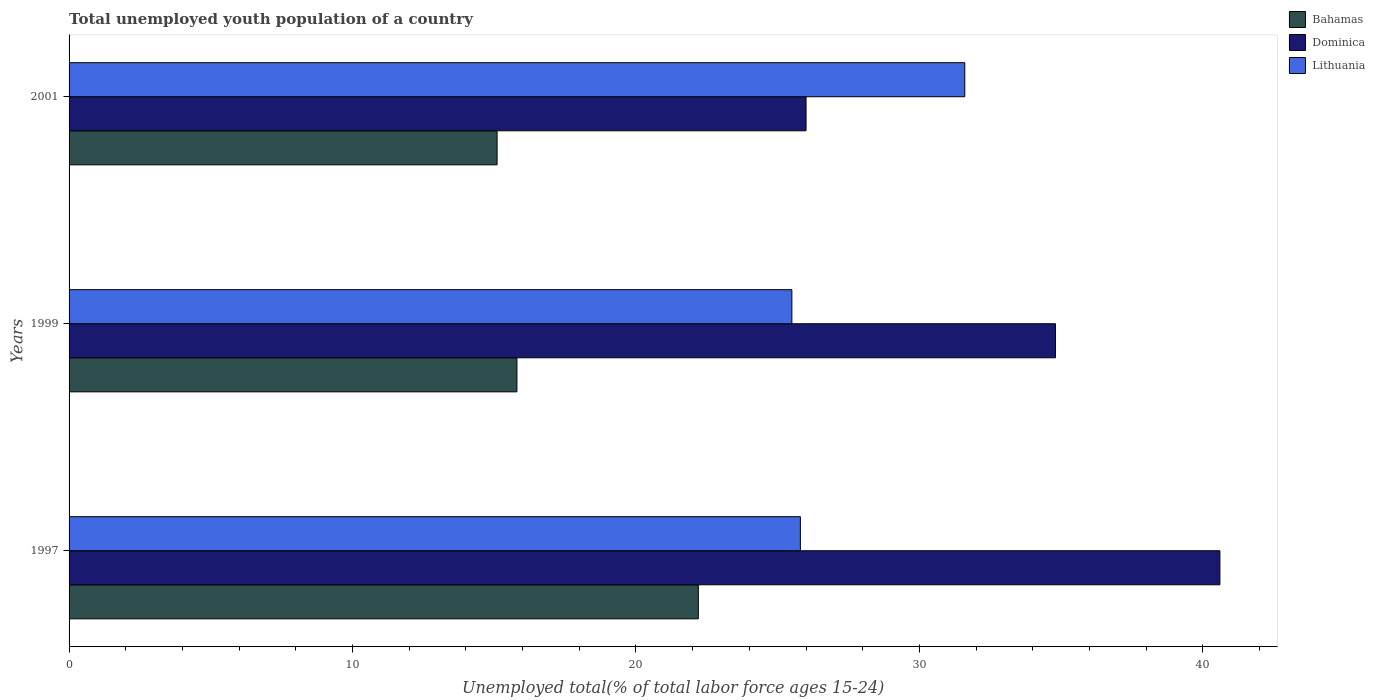Are the number of bars per tick equal to the number of legend labels?
Your answer should be very brief. Yes. What is the label of the 3rd group of bars from the top?
Your answer should be compact. 1997. In how many cases, is the number of bars for a given year not equal to the number of legend labels?
Ensure brevity in your answer.  0. What is the percentage of total unemployed youth population of a country in Dominica in 1999?
Offer a very short reply. 34.8. Across all years, what is the maximum percentage of total unemployed youth population of a country in Dominica?
Ensure brevity in your answer.  40.6. Across all years, what is the minimum percentage of total unemployed youth population of a country in Bahamas?
Provide a succinct answer. 15.1. What is the total percentage of total unemployed youth population of a country in Lithuania in the graph?
Your response must be concise. 82.9. What is the difference between the percentage of total unemployed youth population of a country in Bahamas in 1997 and that in 1999?
Your answer should be compact. 6.4. What is the difference between the percentage of total unemployed youth population of a country in Dominica in 1997 and the percentage of total unemployed youth population of a country in Bahamas in 1999?
Offer a very short reply. 24.8. What is the average percentage of total unemployed youth population of a country in Bahamas per year?
Offer a very short reply. 17.7. In the year 1997, what is the difference between the percentage of total unemployed youth population of a country in Dominica and percentage of total unemployed youth population of a country in Lithuania?
Provide a short and direct response. 14.8. In how many years, is the percentage of total unemployed youth population of a country in Bahamas greater than 18 %?
Provide a short and direct response. 1. What is the ratio of the percentage of total unemployed youth population of a country in Lithuania in 1997 to that in 1999?
Keep it short and to the point. 1.01. Is the percentage of total unemployed youth population of a country in Lithuania in 1999 less than that in 2001?
Offer a very short reply. Yes. What is the difference between the highest and the second highest percentage of total unemployed youth population of a country in Lithuania?
Your answer should be very brief. 5.8. What is the difference between the highest and the lowest percentage of total unemployed youth population of a country in Lithuania?
Your answer should be compact. 6.1. In how many years, is the percentage of total unemployed youth population of a country in Lithuania greater than the average percentage of total unemployed youth population of a country in Lithuania taken over all years?
Give a very brief answer. 1. What does the 1st bar from the top in 2001 represents?
Your answer should be very brief. Lithuania. What does the 2nd bar from the bottom in 2001 represents?
Make the answer very short. Dominica. Is it the case that in every year, the sum of the percentage of total unemployed youth population of a country in Dominica and percentage of total unemployed youth population of a country in Lithuania is greater than the percentage of total unemployed youth population of a country in Bahamas?
Your answer should be compact. Yes. How many bars are there?
Offer a terse response. 9. Are all the bars in the graph horizontal?
Ensure brevity in your answer.  Yes. How many years are there in the graph?
Keep it short and to the point. 3. What is the difference between two consecutive major ticks on the X-axis?
Your response must be concise. 10. Where does the legend appear in the graph?
Provide a short and direct response. Top right. How many legend labels are there?
Keep it short and to the point. 3. How are the legend labels stacked?
Ensure brevity in your answer.  Vertical. What is the title of the graph?
Your response must be concise. Total unemployed youth population of a country. What is the label or title of the X-axis?
Keep it short and to the point. Unemployed total(% of total labor force ages 15-24). What is the Unemployed total(% of total labor force ages 15-24) of Bahamas in 1997?
Provide a succinct answer. 22.2. What is the Unemployed total(% of total labor force ages 15-24) of Dominica in 1997?
Ensure brevity in your answer.  40.6. What is the Unemployed total(% of total labor force ages 15-24) in Lithuania in 1997?
Your answer should be very brief. 25.8. What is the Unemployed total(% of total labor force ages 15-24) of Bahamas in 1999?
Ensure brevity in your answer.  15.8. What is the Unemployed total(% of total labor force ages 15-24) in Dominica in 1999?
Give a very brief answer. 34.8. What is the Unemployed total(% of total labor force ages 15-24) of Lithuania in 1999?
Keep it short and to the point. 25.5. What is the Unemployed total(% of total labor force ages 15-24) in Bahamas in 2001?
Ensure brevity in your answer.  15.1. What is the Unemployed total(% of total labor force ages 15-24) of Dominica in 2001?
Keep it short and to the point. 26. What is the Unemployed total(% of total labor force ages 15-24) in Lithuania in 2001?
Make the answer very short. 31.6. Across all years, what is the maximum Unemployed total(% of total labor force ages 15-24) in Bahamas?
Provide a short and direct response. 22.2. Across all years, what is the maximum Unemployed total(% of total labor force ages 15-24) of Dominica?
Your answer should be compact. 40.6. Across all years, what is the maximum Unemployed total(% of total labor force ages 15-24) of Lithuania?
Provide a succinct answer. 31.6. Across all years, what is the minimum Unemployed total(% of total labor force ages 15-24) in Bahamas?
Ensure brevity in your answer.  15.1. Across all years, what is the minimum Unemployed total(% of total labor force ages 15-24) of Dominica?
Make the answer very short. 26. Across all years, what is the minimum Unemployed total(% of total labor force ages 15-24) in Lithuania?
Make the answer very short. 25.5. What is the total Unemployed total(% of total labor force ages 15-24) of Bahamas in the graph?
Your answer should be very brief. 53.1. What is the total Unemployed total(% of total labor force ages 15-24) of Dominica in the graph?
Offer a terse response. 101.4. What is the total Unemployed total(% of total labor force ages 15-24) in Lithuania in the graph?
Give a very brief answer. 82.9. What is the difference between the Unemployed total(% of total labor force ages 15-24) in Lithuania in 1997 and that in 1999?
Give a very brief answer. 0.3. What is the difference between the Unemployed total(% of total labor force ages 15-24) in Dominica in 1997 and that in 2001?
Make the answer very short. 14.6. What is the difference between the Unemployed total(% of total labor force ages 15-24) of Bahamas in 1999 and that in 2001?
Provide a short and direct response. 0.7. What is the difference between the Unemployed total(% of total labor force ages 15-24) in Dominica in 1997 and the Unemployed total(% of total labor force ages 15-24) in Lithuania in 1999?
Provide a succinct answer. 15.1. What is the difference between the Unemployed total(% of total labor force ages 15-24) in Bahamas in 1997 and the Unemployed total(% of total labor force ages 15-24) in Dominica in 2001?
Provide a succinct answer. -3.8. What is the difference between the Unemployed total(% of total labor force ages 15-24) of Dominica in 1997 and the Unemployed total(% of total labor force ages 15-24) of Lithuania in 2001?
Your answer should be very brief. 9. What is the difference between the Unemployed total(% of total labor force ages 15-24) in Bahamas in 1999 and the Unemployed total(% of total labor force ages 15-24) in Dominica in 2001?
Give a very brief answer. -10.2. What is the difference between the Unemployed total(% of total labor force ages 15-24) in Bahamas in 1999 and the Unemployed total(% of total labor force ages 15-24) in Lithuania in 2001?
Your response must be concise. -15.8. What is the difference between the Unemployed total(% of total labor force ages 15-24) of Dominica in 1999 and the Unemployed total(% of total labor force ages 15-24) of Lithuania in 2001?
Your response must be concise. 3.2. What is the average Unemployed total(% of total labor force ages 15-24) of Dominica per year?
Provide a short and direct response. 33.8. What is the average Unemployed total(% of total labor force ages 15-24) in Lithuania per year?
Offer a terse response. 27.63. In the year 1997, what is the difference between the Unemployed total(% of total labor force ages 15-24) in Bahamas and Unemployed total(% of total labor force ages 15-24) in Dominica?
Ensure brevity in your answer.  -18.4. In the year 1997, what is the difference between the Unemployed total(% of total labor force ages 15-24) of Bahamas and Unemployed total(% of total labor force ages 15-24) of Lithuania?
Provide a short and direct response. -3.6. In the year 1999, what is the difference between the Unemployed total(% of total labor force ages 15-24) of Bahamas and Unemployed total(% of total labor force ages 15-24) of Lithuania?
Keep it short and to the point. -9.7. In the year 1999, what is the difference between the Unemployed total(% of total labor force ages 15-24) of Dominica and Unemployed total(% of total labor force ages 15-24) of Lithuania?
Offer a terse response. 9.3. In the year 2001, what is the difference between the Unemployed total(% of total labor force ages 15-24) in Bahamas and Unemployed total(% of total labor force ages 15-24) in Lithuania?
Give a very brief answer. -16.5. What is the ratio of the Unemployed total(% of total labor force ages 15-24) in Bahamas in 1997 to that in 1999?
Your response must be concise. 1.41. What is the ratio of the Unemployed total(% of total labor force ages 15-24) of Dominica in 1997 to that in 1999?
Provide a short and direct response. 1.17. What is the ratio of the Unemployed total(% of total labor force ages 15-24) in Lithuania in 1997 to that in 1999?
Provide a succinct answer. 1.01. What is the ratio of the Unemployed total(% of total labor force ages 15-24) in Bahamas in 1997 to that in 2001?
Offer a terse response. 1.47. What is the ratio of the Unemployed total(% of total labor force ages 15-24) in Dominica in 1997 to that in 2001?
Provide a succinct answer. 1.56. What is the ratio of the Unemployed total(% of total labor force ages 15-24) of Lithuania in 1997 to that in 2001?
Offer a very short reply. 0.82. What is the ratio of the Unemployed total(% of total labor force ages 15-24) of Bahamas in 1999 to that in 2001?
Give a very brief answer. 1.05. What is the ratio of the Unemployed total(% of total labor force ages 15-24) in Dominica in 1999 to that in 2001?
Keep it short and to the point. 1.34. What is the ratio of the Unemployed total(% of total labor force ages 15-24) in Lithuania in 1999 to that in 2001?
Keep it short and to the point. 0.81. What is the difference between the highest and the second highest Unemployed total(% of total labor force ages 15-24) in Bahamas?
Provide a short and direct response. 6.4. What is the difference between the highest and the second highest Unemployed total(% of total labor force ages 15-24) in Dominica?
Your answer should be compact. 5.8. What is the difference between the highest and the second highest Unemployed total(% of total labor force ages 15-24) in Lithuania?
Offer a very short reply. 5.8. What is the difference between the highest and the lowest Unemployed total(% of total labor force ages 15-24) in Bahamas?
Your answer should be compact. 7.1. What is the difference between the highest and the lowest Unemployed total(% of total labor force ages 15-24) of Lithuania?
Your response must be concise. 6.1. 